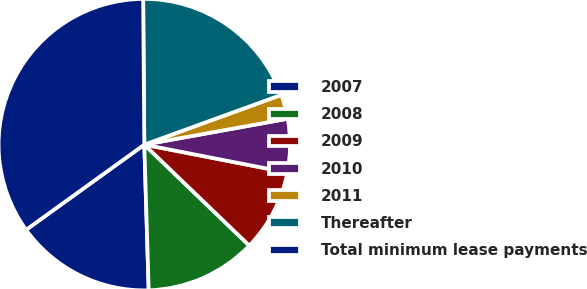Convert chart. <chart><loc_0><loc_0><loc_500><loc_500><pie_chart><fcel>2007<fcel>2008<fcel>2009<fcel>2010<fcel>2011<fcel>Thereafter<fcel>Total minimum lease payments<nl><fcel>15.54%<fcel>12.33%<fcel>9.12%<fcel>5.91%<fcel>2.7%<fcel>19.58%<fcel>34.81%<nl></chart> 